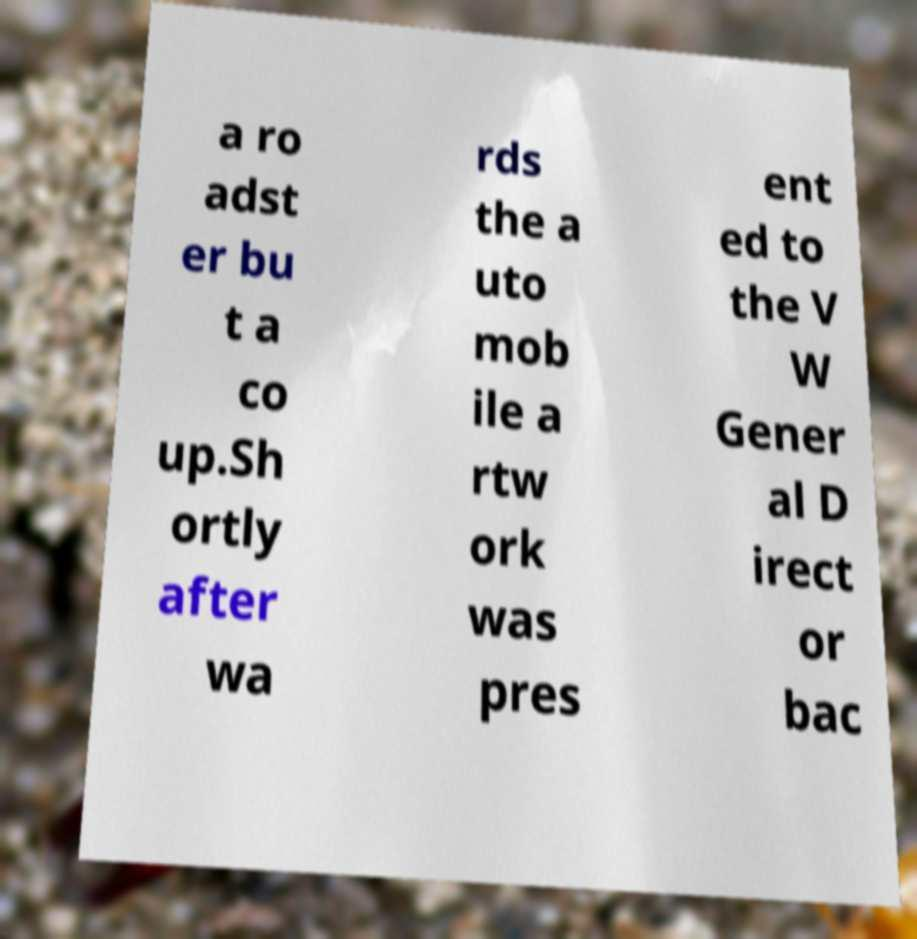Please read and relay the text visible in this image. What does it say? a ro adst er bu t a co up.Sh ortly after wa rds the a uto mob ile a rtw ork was pres ent ed to the V W Gener al D irect or bac 